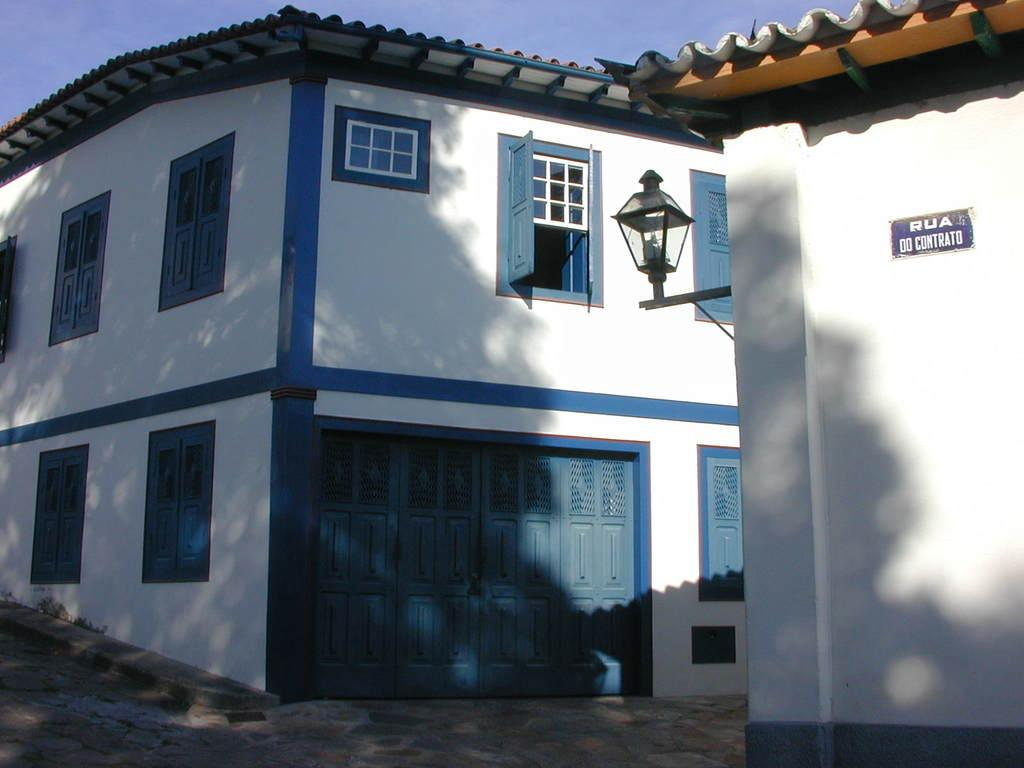What type of structures are present in the image? There are buildings in the image. What type of lighting is present in the image? There is a street lamp in the image. What architectural features can be seen on the buildings? There are windows and doors in the image. What is visible at the top of the image? The sky is visible at the top of the image. How many bones can be seen scattered on the ground in the image? There are no bones visible in the image. What type of spiders can be seen crawling on the buildings in the image? There are no spiders present in the image. 